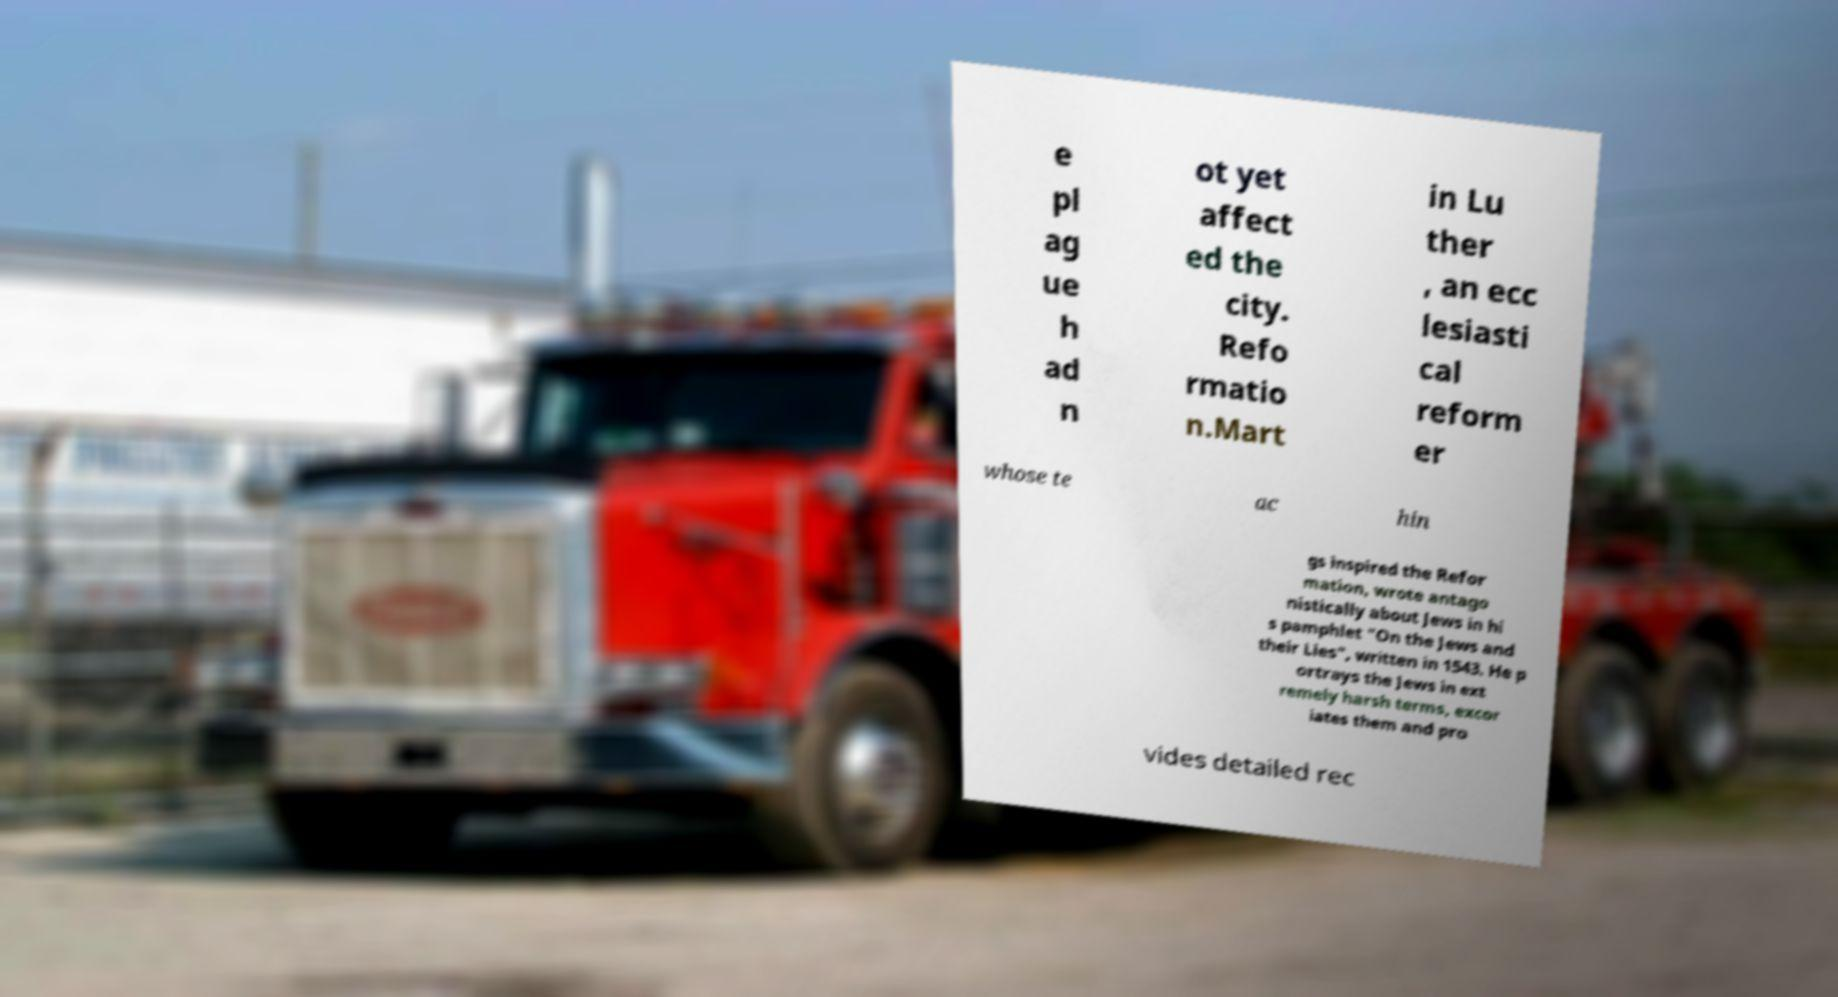I need the written content from this picture converted into text. Can you do that? e pl ag ue h ad n ot yet affect ed the city. Refo rmatio n.Mart in Lu ther , an ecc lesiasti cal reform er whose te ac hin gs inspired the Refor mation, wrote antago nistically about Jews in hi s pamphlet "On the Jews and their Lies", written in 1543. He p ortrays the Jews in ext remely harsh terms, excor iates them and pro vides detailed rec 